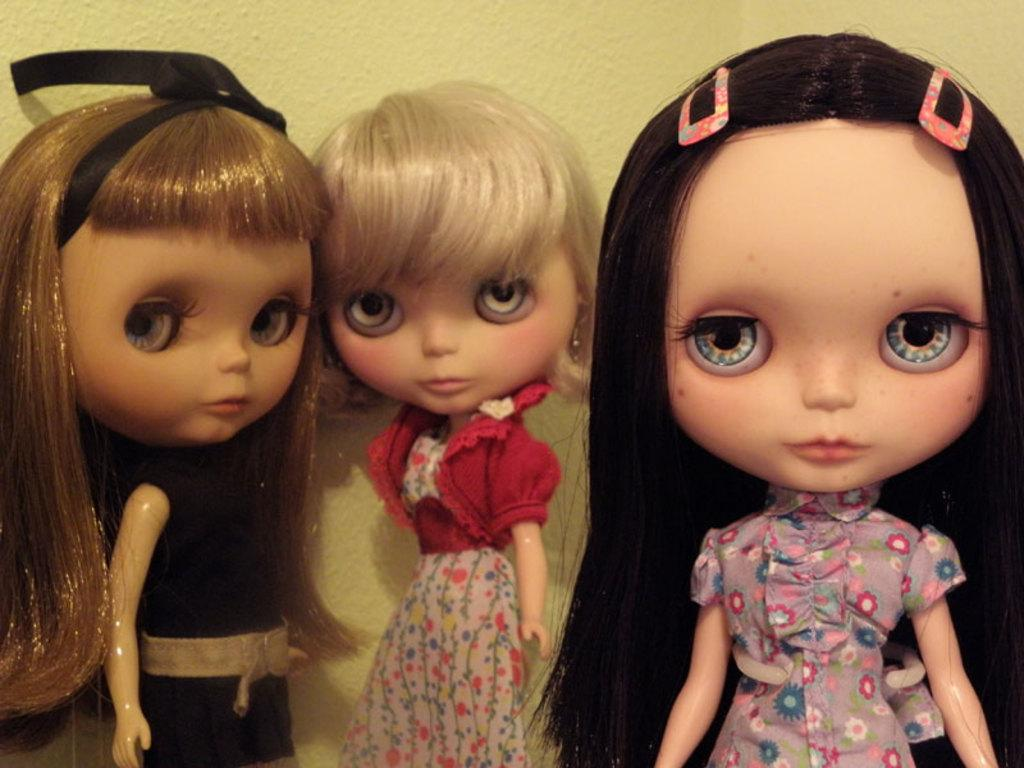How many dolls are present in the image? There are three dolls in the image. What can be seen in the background of the image? There is a wall visible in the image. What type of gun is being held by one of the dolls in the image? There are no guns present in the image; it only features three dolls and a wall in the background. 